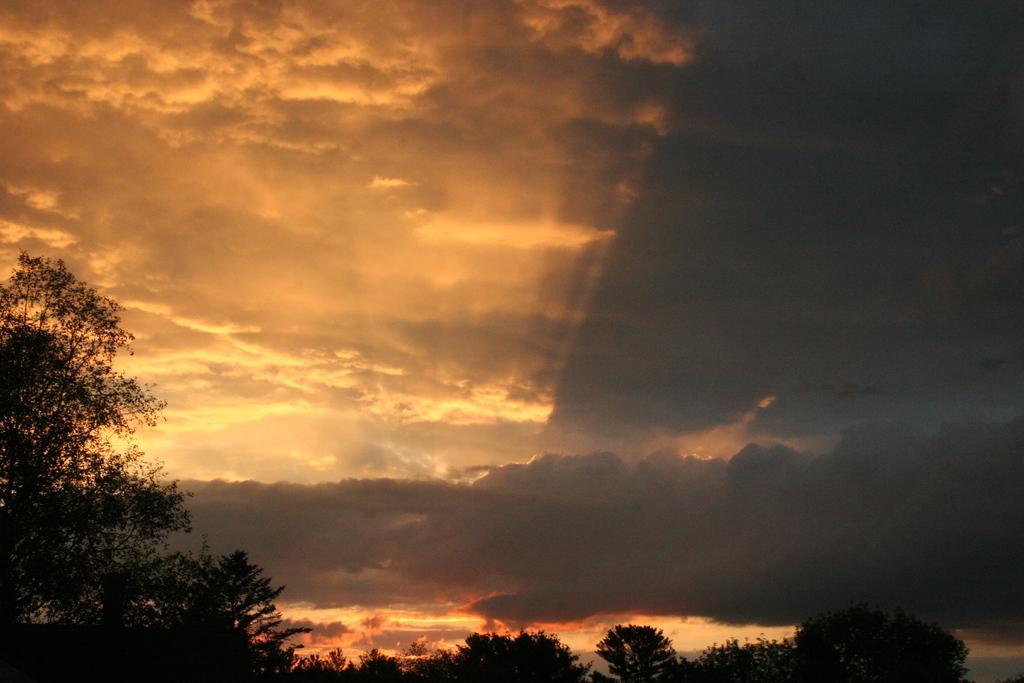Describe this image in one or two sentences. In this image I can see few trees and the sky is in orange, black and white color. 